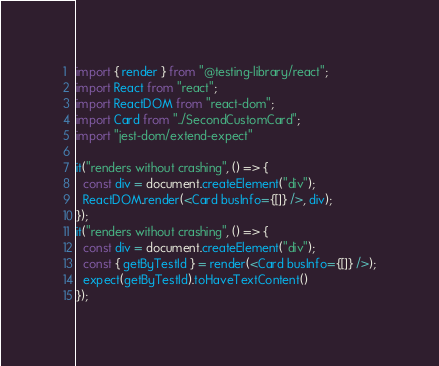<code> <loc_0><loc_0><loc_500><loc_500><_JavaScript_>import { render } from "@testing-library/react";
import React from "react";
import ReactDOM from "react-dom";
import Card from "../SecondCustomCard";
import "jest-dom/extend-expect"

it("renders without crashing", () => {
  const div = document.createElement("div");
  ReactDOM.render(<Card busInfo={[]} />, div);
});
it("renders without crashing", () => {
  const div = document.createElement("div");
  const { getByTestId } = render(<Card busInfo={[]} />);
  expect(getByTestId).toHaveTextContent()
});
</code> 